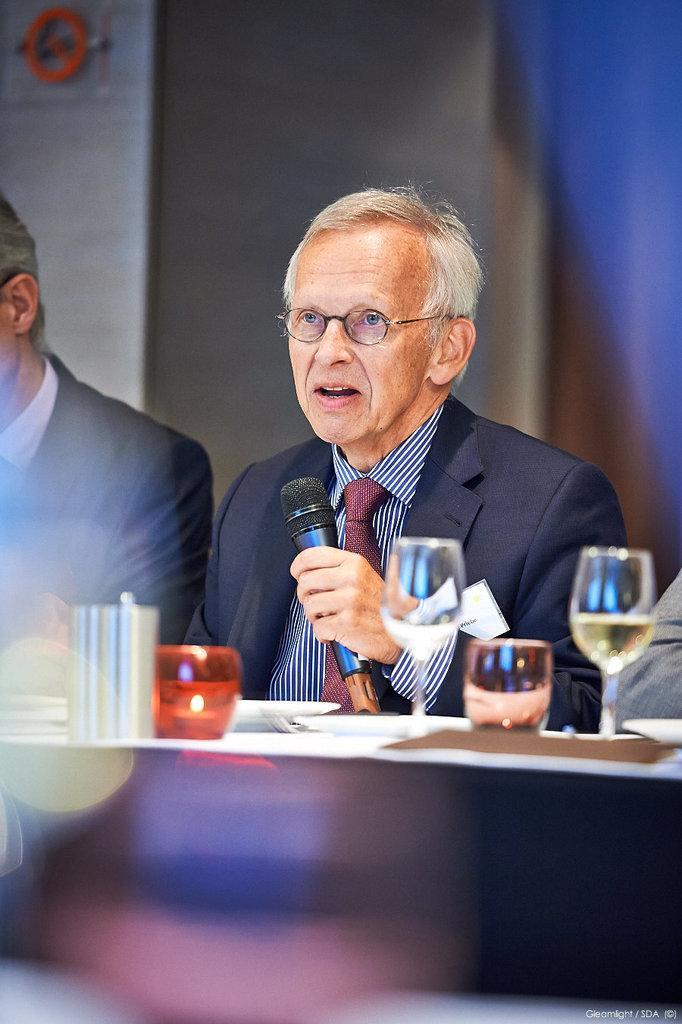Please provide a concise description of this image. There is a man who is talking on the mike. He has spectacles and he is in a suit. Besides him there is a person. This is table. On the table there are glasses. 